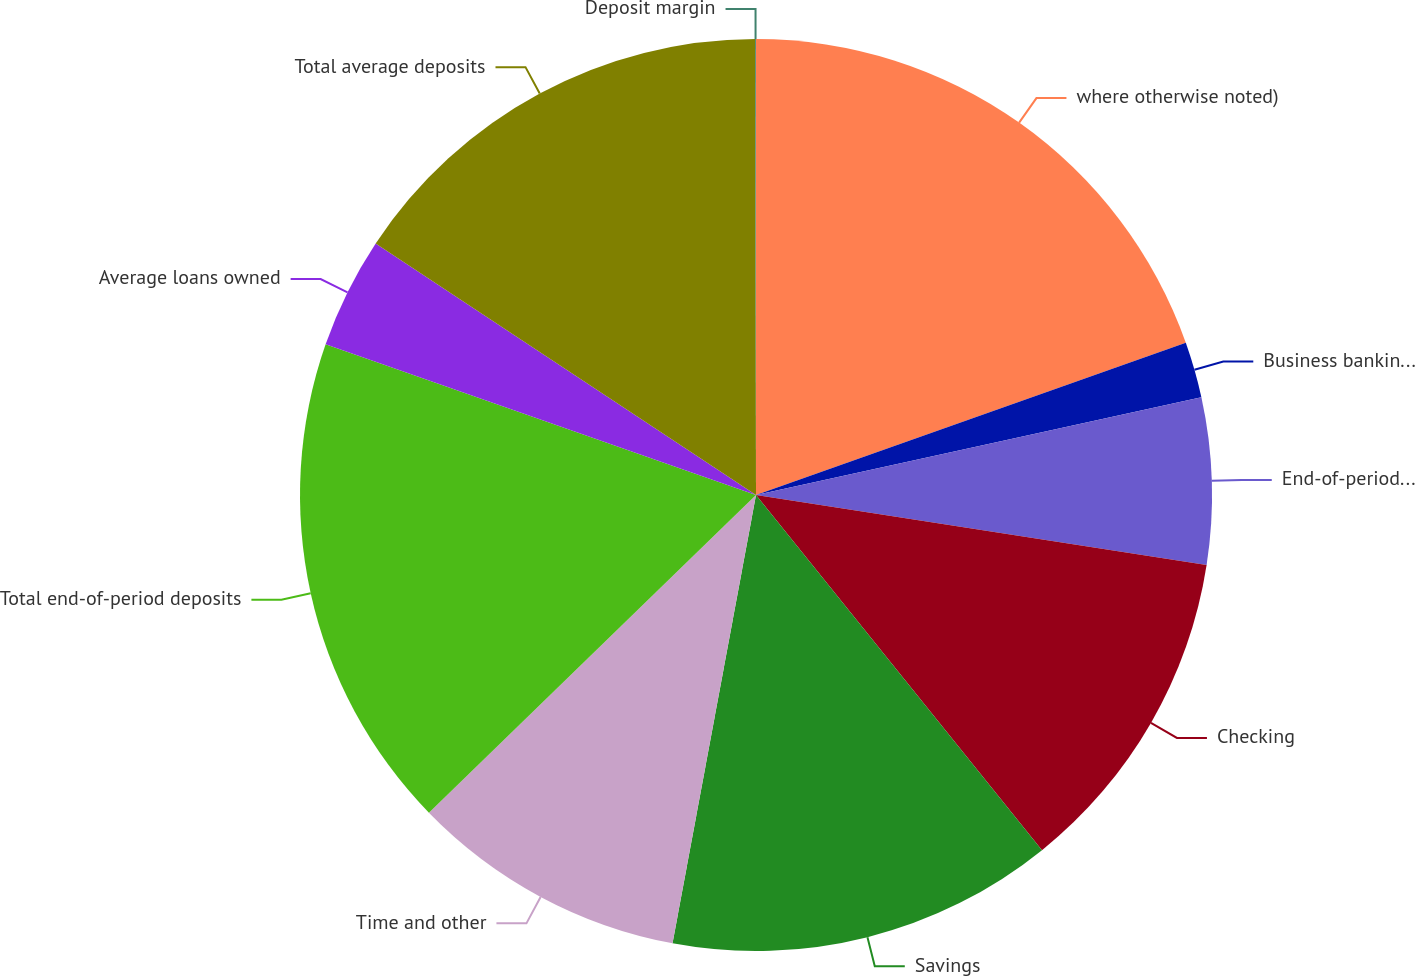<chart> <loc_0><loc_0><loc_500><loc_500><pie_chart><fcel>where otherwise noted)<fcel>Business banking origination<fcel>End-of-period loans owned<fcel>Checking<fcel>Savings<fcel>Time and other<fcel>Total end-of-period deposits<fcel>Average loans owned<fcel>Total average deposits<fcel>Deposit margin<nl><fcel>19.58%<fcel>1.98%<fcel>5.89%<fcel>11.76%<fcel>13.72%<fcel>9.8%<fcel>17.63%<fcel>3.94%<fcel>15.67%<fcel>0.03%<nl></chart> 